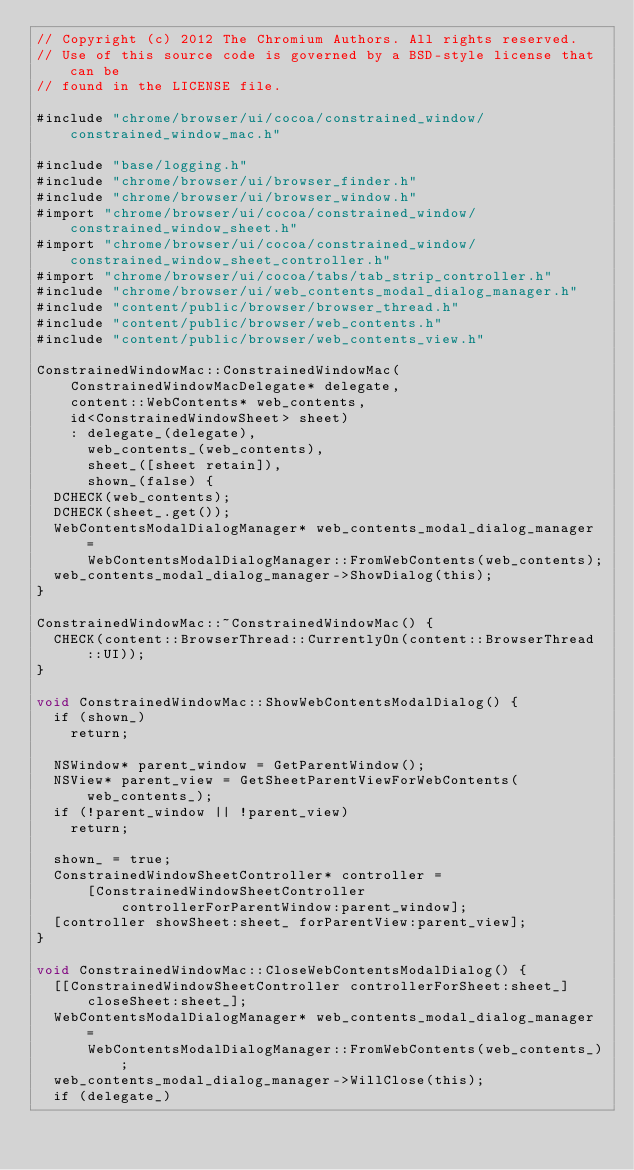<code> <loc_0><loc_0><loc_500><loc_500><_ObjectiveC_>// Copyright (c) 2012 The Chromium Authors. All rights reserved.
// Use of this source code is governed by a BSD-style license that can be
// found in the LICENSE file.

#include "chrome/browser/ui/cocoa/constrained_window/constrained_window_mac.h"

#include "base/logging.h"
#include "chrome/browser/ui/browser_finder.h"
#include "chrome/browser/ui/browser_window.h"
#import "chrome/browser/ui/cocoa/constrained_window/constrained_window_sheet.h"
#import "chrome/browser/ui/cocoa/constrained_window/constrained_window_sheet_controller.h"
#import "chrome/browser/ui/cocoa/tabs/tab_strip_controller.h"
#include "chrome/browser/ui/web_contents_modal_dialog_manager.h"
#include "content/public/browser/browser_thread.h"
#include "content/public/browser/web_contents.h"
#include "content/public/browser/web_contents_view.h"

ConstrainedWindowMac::ConstrainedWindowMac(
    ConstrainedWindowMacDelegate* delegate,
    content::WebContents* web_contents,
    id<ConstrainedWindowSheet> sheet)
    : delegate_(delegate),
      web_contents_(web_contents),
      sheet_([sheet retain]),
      shown_(false) {
  DCHECK(web_contents);
  DCHECK(sheet_.get());
  WebContentsModalDialogManager* web_contents_modal_dialog_manager =
      WebContentsModalDialogManager::FromWebContents(web_contents);
  web_contents_modal_dialog_manager->ShowDialog(this);
}

ConstrainedWindowMac::~ConstrainedWindowMac() {
  CHECK(content::BrowserThread::CurrentlyOn(content::BrowserThread::UI));
}

void ConstrainedWindowMac::ShowWebContentsModalDialog() {
  if (shown_)
    return;

  NSWindow* parent_window = GetParentWindow();
  NSView* parent_view = GetSheetParentViewForWebContents(web_contents_);
  if (!parent_window || !parent_view)
    return;

  shown_ = true;
  ConstrainedWindowSheetController* controller =
      [ConstrainedWindowSheetController
          controllerForParentWindow:parent_window];
  [controller showSheet:sheet_ forParentView:parent_view];
}

void ConstrainedWindowMac::CloseWebContentsModalDialog() {
  [[ConstrainedWindowSheetController controllerForSheet:sheet_]
      closeSheet:sheet_];
  WebContentsModalDialogManager* web_contents_modal_dialog_manager =
      WebContentsModalDialogManager::FromWebContents(web_contents_);
  web_contents_modal_dialog_manager->WillClose(this);
  if (delegate_)</code> 